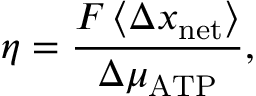<formula> <loc_0><loc_0><loc_500><loc_500>\eta = \frac { F \left \langle \Delta x _ { n e t } \right \rangle } { \Delta \mu _ { A T P } } ,</formula> 